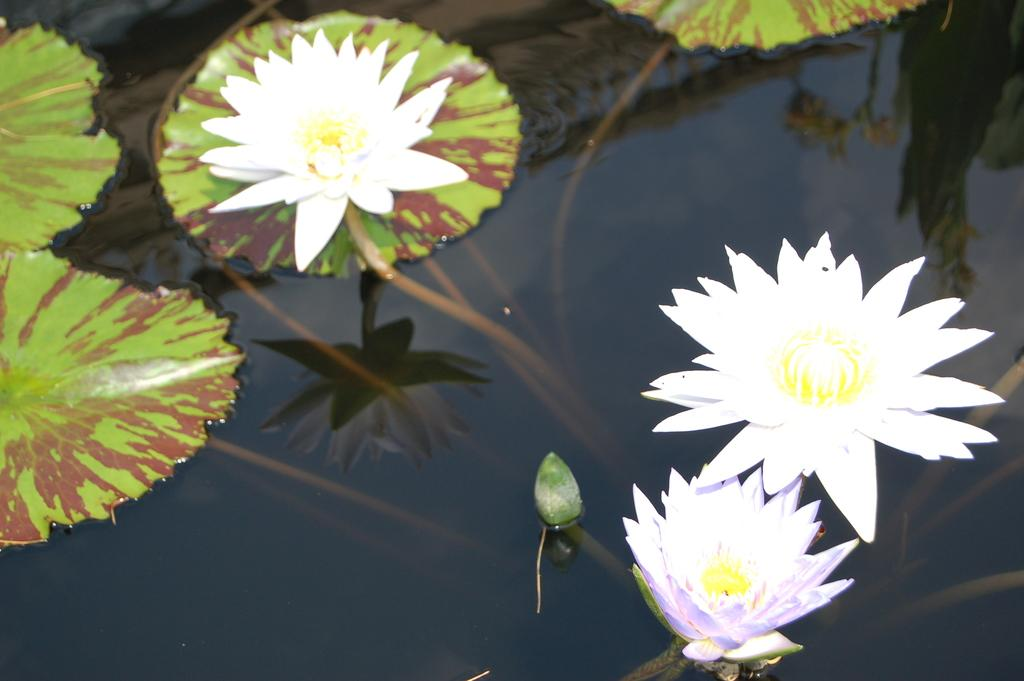What type of flowers are in the image? There are lotus flowers in the image. Where are the lotus flowers located? The lotus flowers are in a water pond. What color are the leaves in the water pond? The water pond has green leaves. What is the best way to transport a cow in the image? There are no cows present in the image, so it is not possible to determine the best way to transport one. 